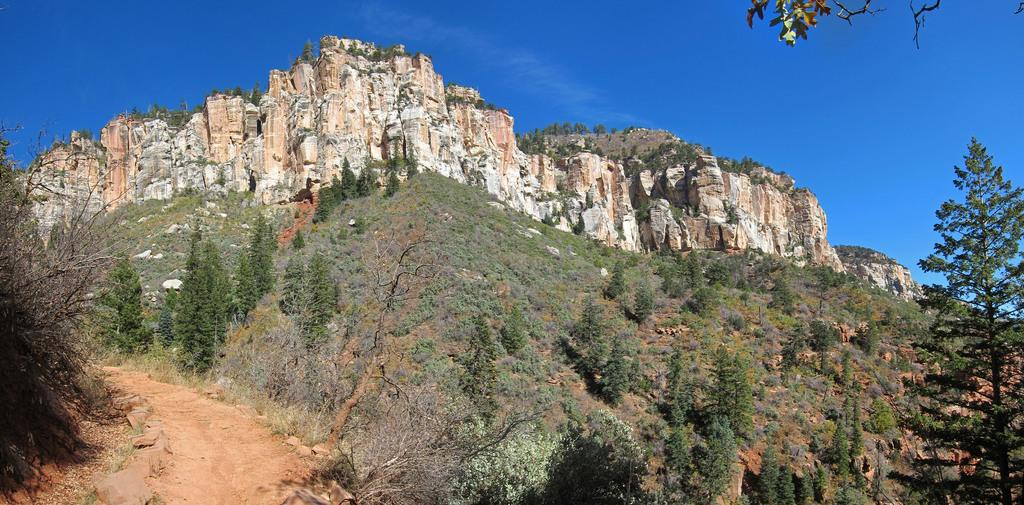What type of vegetation is present in the front of the image? There are trees in the front of the image. What type of landscape feature can be seen in the background of the image? There are hills in the background of the image. What is visible at the top of the image? The sky is visible at the top of the image. How many dogs are sitting on the drain in the image? There are no dogs or drains present in the image. 